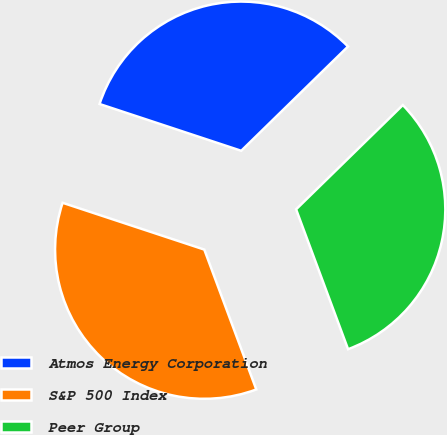Convert chart. <chart><loc_0><loc_0><loc_500><loc_500><pie_chart><fcel>Atmos Energy Corporation<fcel>S&P 500 Index<fcel>Peer Group<nl><fcel>32.61%<fcel>35.74%<fcel>31.65%<nl></chart> 